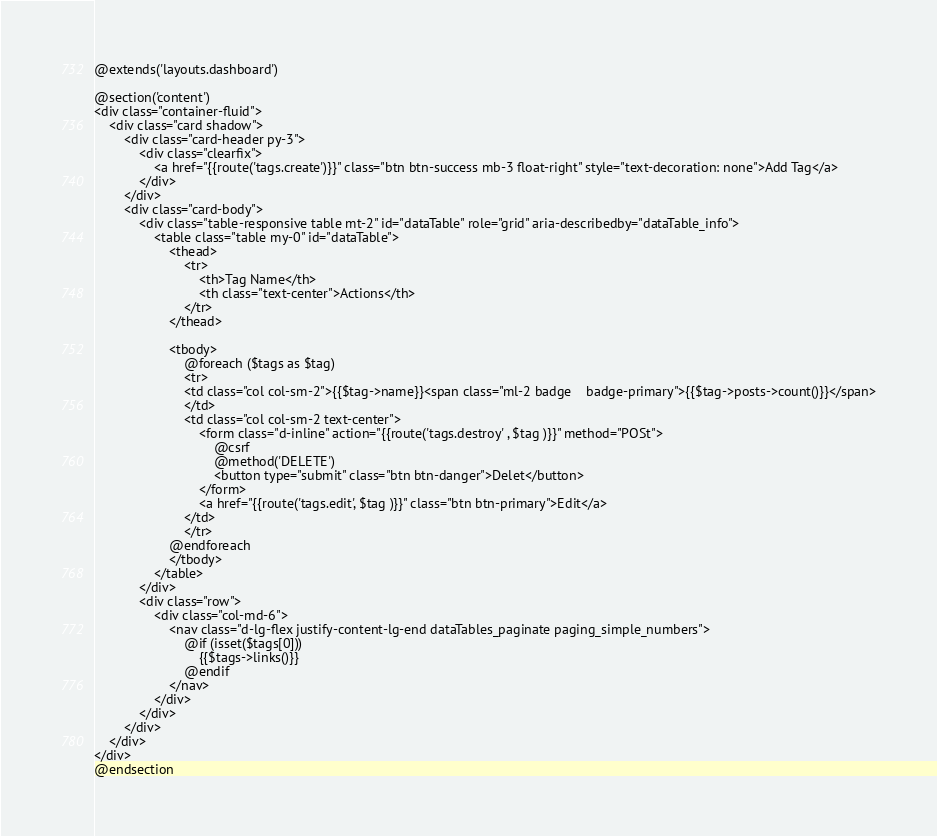Convert code to text. <code><loc_0><loc_0><loc_500><loc_500><_PHP_>@extends('layouts.dashboard')

@section('content')
<div class="container-fluid">
    <div class="card shadow">
        <div class="card-header py-3">
            <div class="clearfix">
                <a href="{{route('tags.create')}}" class="btn btn-success mb-3 float-right" style="text-decoration: none">Add Tag</a>
            </div>
        </div>
        <div class="card-body">
            <div class="table-responsive table mt-2" id="dataTable" role="grid" aria-describedby="dataTable_info">
                <table class="table my-0" id="dataTable">
                    <thead>
                        <tr>
                            <th>Tag Name</th>
                            <th class="text-center">Actions</th>
                        </tr>
                    </thead>

                    <tbody>
                        @foreach ($tags as $tag)
                        <tr>
                        <td class="col col-sm-2">{{$tag->name}}<span class="ml-2 badge    badge-primary">{{$tag->posts->count()}}</span>
                        </td>
                        <td class="col col-sm-2 text-center">
                            <form class="d-inline" action="{{route('tags.destroy' , $tag )}}" method="POSt">
                                @csrf
                                @method('DELETE')
                                <button type="submit" class="btn btn-danger">Delet</button>
                            </form>
                            <a href="{{route('tags.edit', $tag )}}" class="btn btn-primary">Edit</a>
                        </td>
                        </tr>
                    @endforeach
                    </tbody>
                </table>
            </div>
            <div class="row">
                <div class="col-md-6">
                    <nav class="d-lg-flex justify-content-lg-end dataTables_paginate paging_simple_numbers">
                        @if (isset($tags[0]))
                            {{$tags->links()}}
                        @endif
                    </nav>
                </div>
            </div>
        </div>
    </div>
</div>
@endsection
</code> 